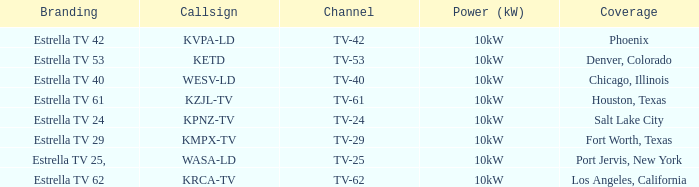Can you give me this table as a dict? {'header': ['Branding', 'Callsign', 'Channel', 'Power (kW)', 'Coverage'], 'rows': [['Estrella TV 42', 'KVPA-LD', 'TV-42', '10kW', 'Phoenix'], ['Estrella TV 53', 'KETD', 'TV-53', '10kW', 'Denver, Colorado'], ['Estrella TV 40', 'WESV-LD', 'TV-40', '10kW', 'Chicago, Illinois'], ['Estrella TV 61', 'KZJL-TV', 'TV-61', '10kW', 'Houston, Texas'], ['Estrella TV 24', 'KPNZ-TV', 'TV-24', '10kW', 'Salt Lake City'], ['Estrella TV 29', 'KMPX-TV', 'TV-29', '10kW', 'Fort Worth, Texas'], ['Estrella TV 25,', 'WASA-LD', 'TV-25', '10kW', 'Port Jervis, New York'], ['Estrella TV 62', 'KRCA-TV', 'TV-62', '10kW', 'Los Angeles, California']]} List the branding name for channel tv-62. Estrella TV 62. 